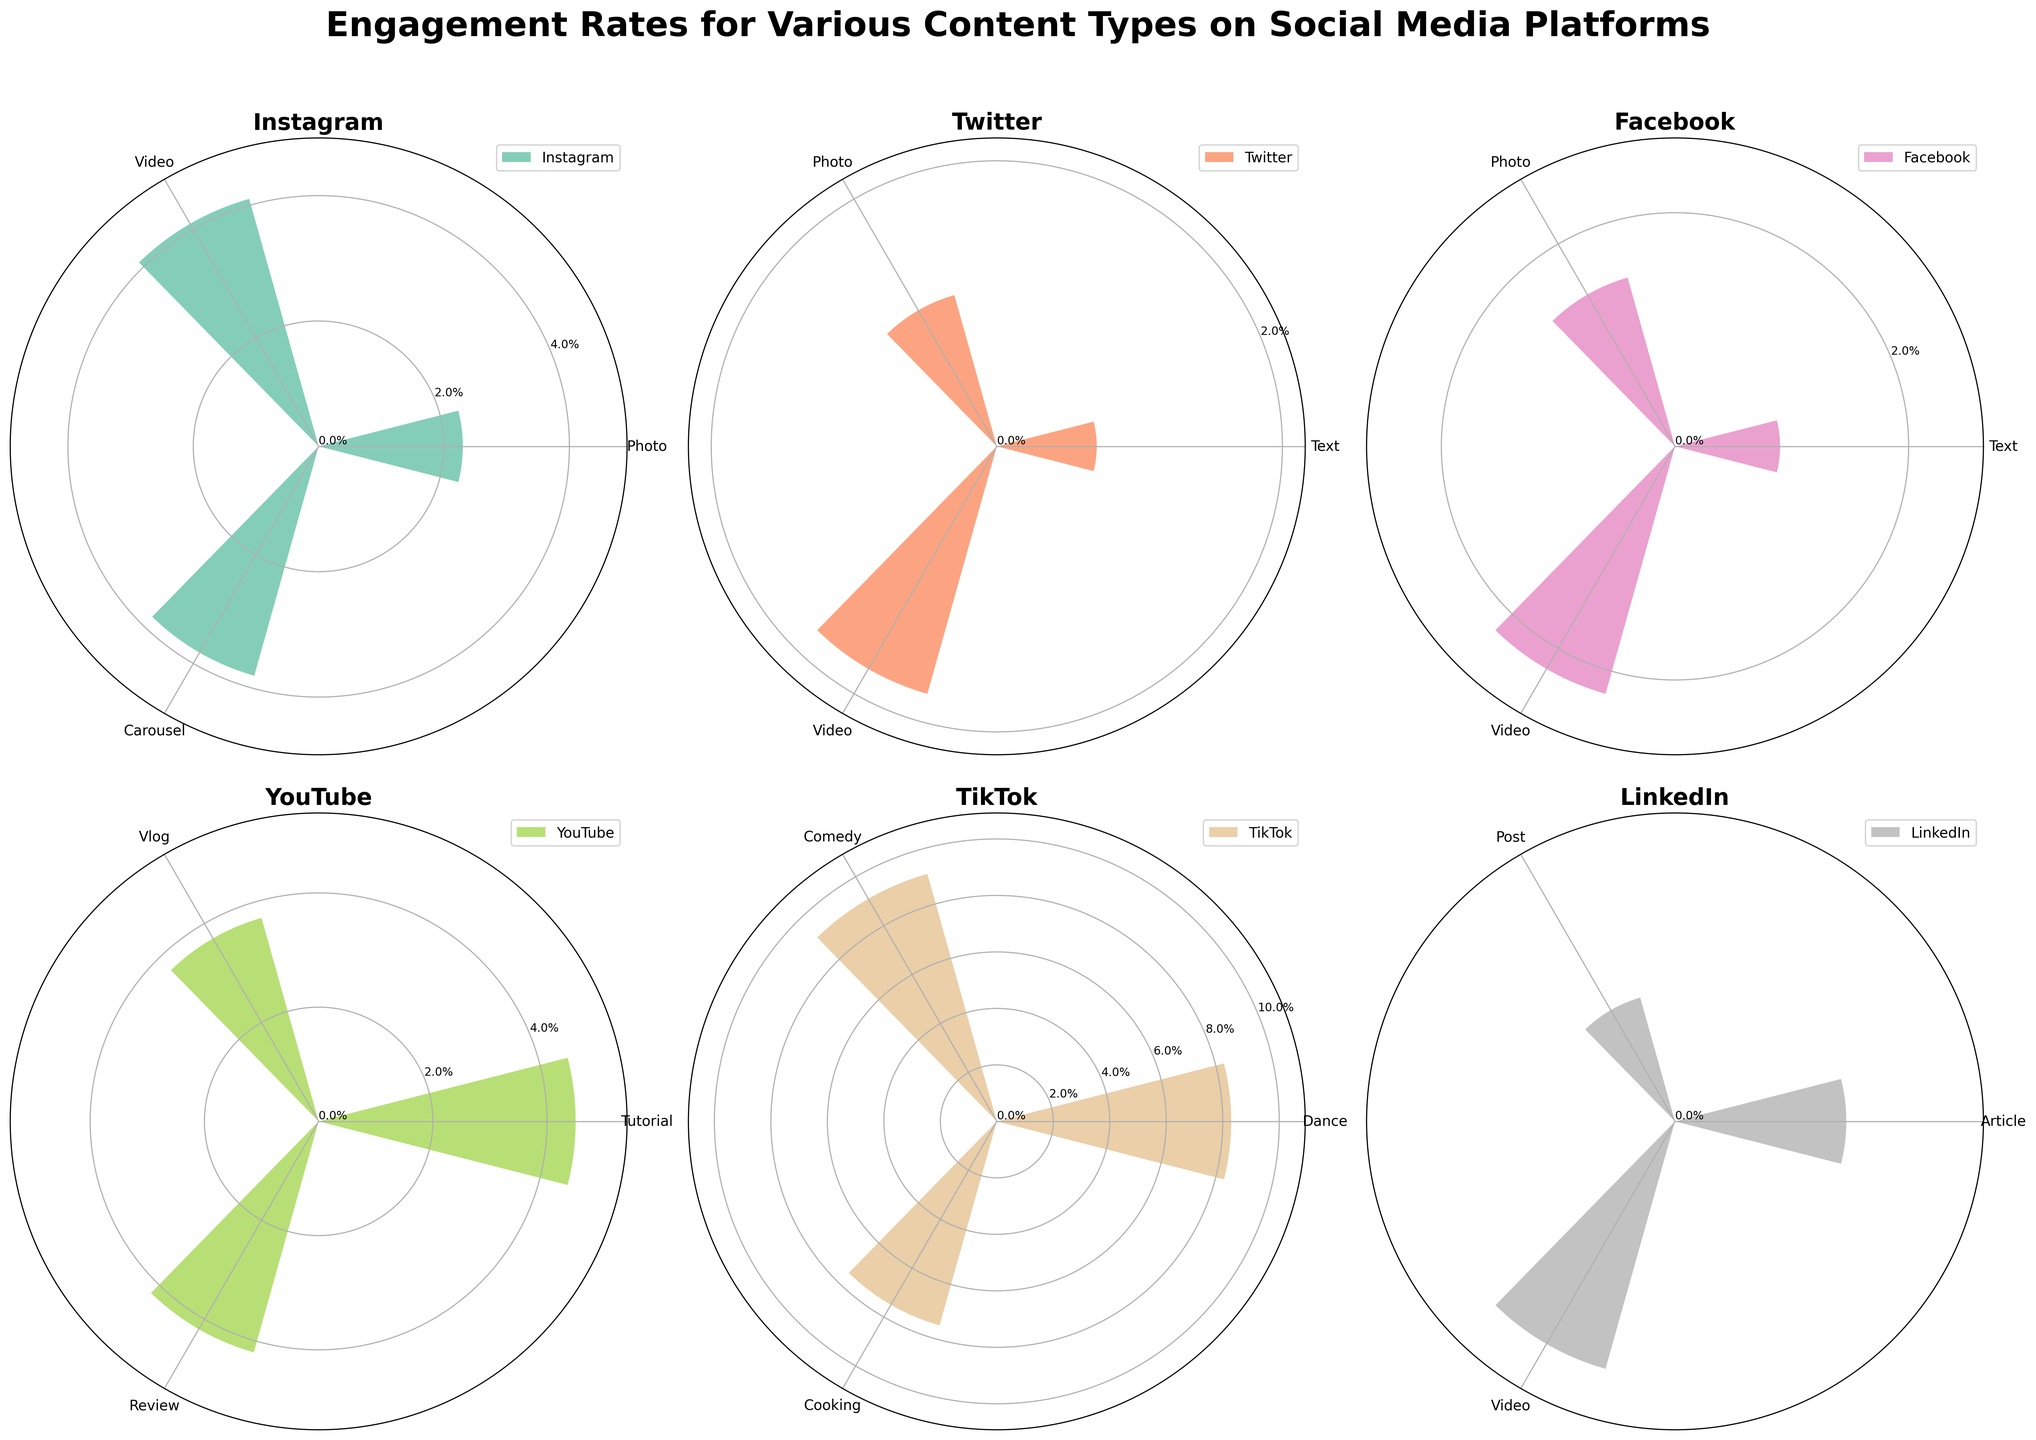What is the platform with the highest engagement rate? By looking at all the platforms, TikTok has the highest engagement rate at around 9.1% for Comedy content
Answer: TikTok Which content type has the highest engagement rate on Twitter? By examining the chart for Twitter, Video content has the highest engagement rate at 1.8%
Answer: Video What is the average engagement rate for content types on Instagram? Instagram data includes engagement rates of 2.3%, 4.1%, and 3.8%. The average is calculated as (2.3 + 4.1 + 3.8) / 3 = 3.4
Answer: 3.4% By how much does YouTube's highest engagement rate differ from Facebook's highest engagement rate? YouTube's highest engagement rate is 4.5% (Tutorial) while Facebook's highest engagement rate is 2.2% (Video), the difference is 4.5 - 2.2 = 2.3%
Answer: 2.3% Which engagement rate is higher: LinkedIn Text or Twitter Text? LinkedIn Text has an engagement rate of 0.8% and Twitter Text has an engagement rate of 0.7%, thus LinkedIn Text is higher
Answer: LinkedIn Text Among the platforms, which one has the most consistent engagement rates across different content types? By comparing the variances, Instagram (2.3%, 4.1%, 3.8%), Twitter (0.7%, 1.1%, 1.8%), Facebook (0.9%, 1.5%, 2.2%), and so on, LinkedIn has relatively consistent rates (0.8%, 0.6%, 1.2%)
Answer: LinkedIn Which content type has the lowest engagement rate on LinkedIn? On LinkedIn, Post content has the lowest engagement rate of 0.6%
Answer: Post What is the difference in engagement rate between TikTok Dance and Cooking content? TikTok's Dance content has an engagement rate of 8.3% and Cooking content has 7.5%, the difference is 8.3 - 7.5 = 0.8%
Answer: 0.8% How much higher is TikTok Comedy engagement rate compared to the highest engagement rate on Instagram? TikTok's Comedy has an engagement rate of 9.1%, while Instagram's highest engagement rate is Video at 4.1%. The difference is 9.1 - 4.1 = 5%
Answer: 5% 